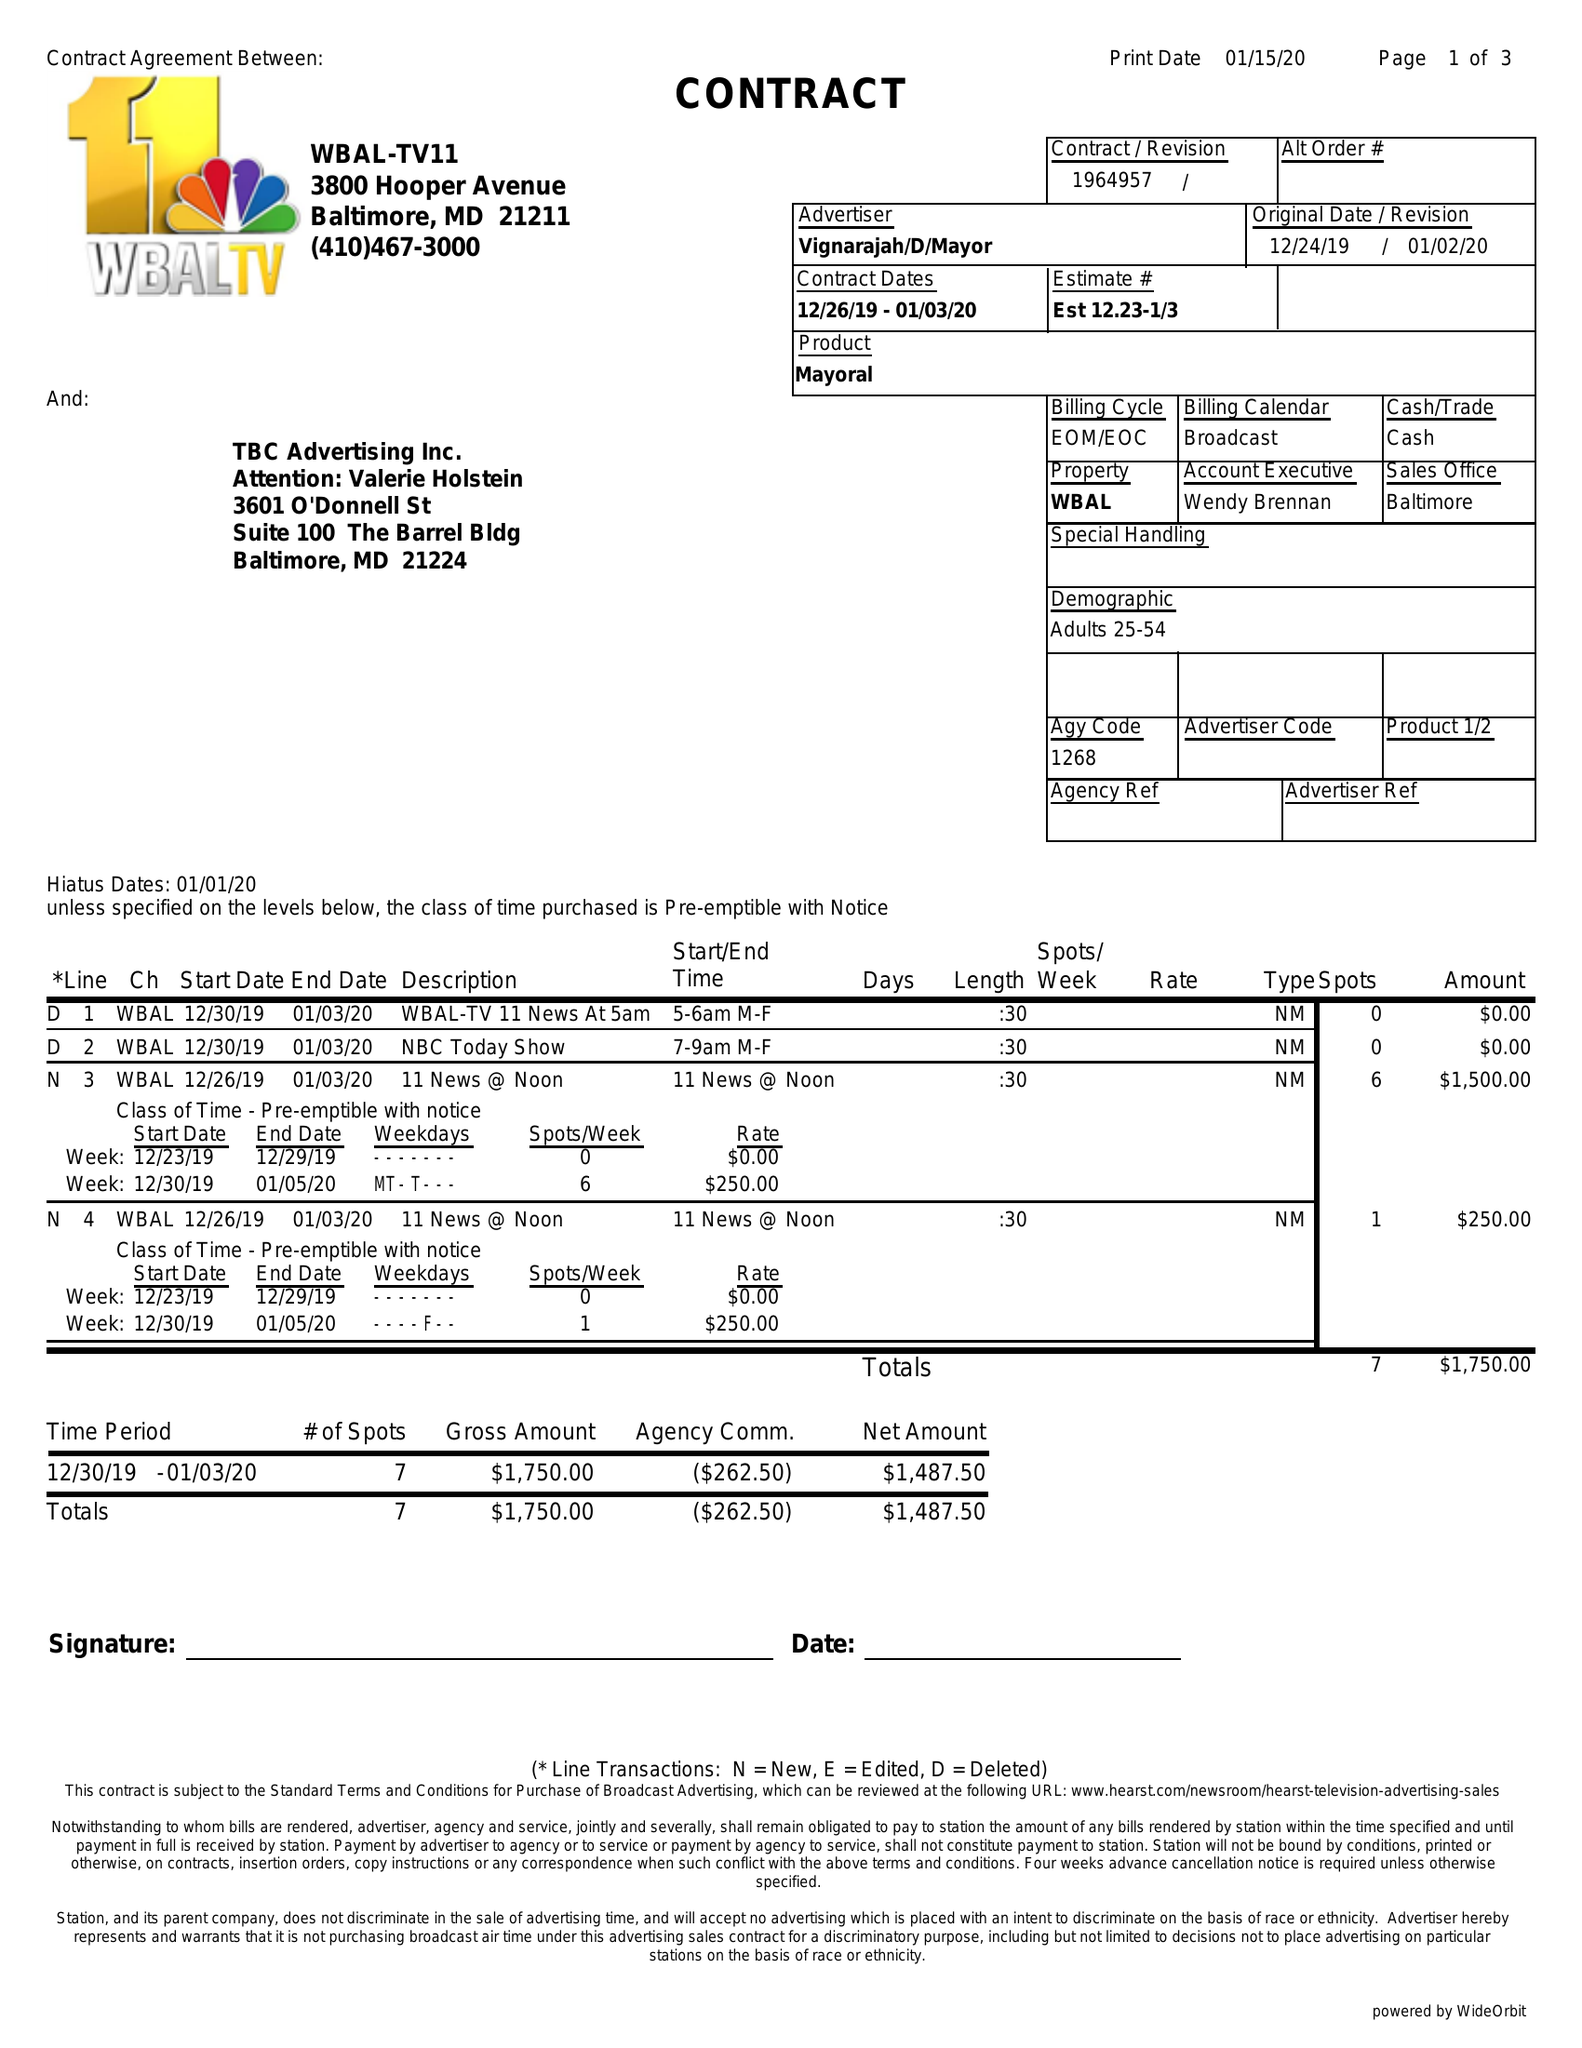What is the value for the advertiser?
Answer the question using a single word or phrase. VIGNARAJAH/D/MAYOR 